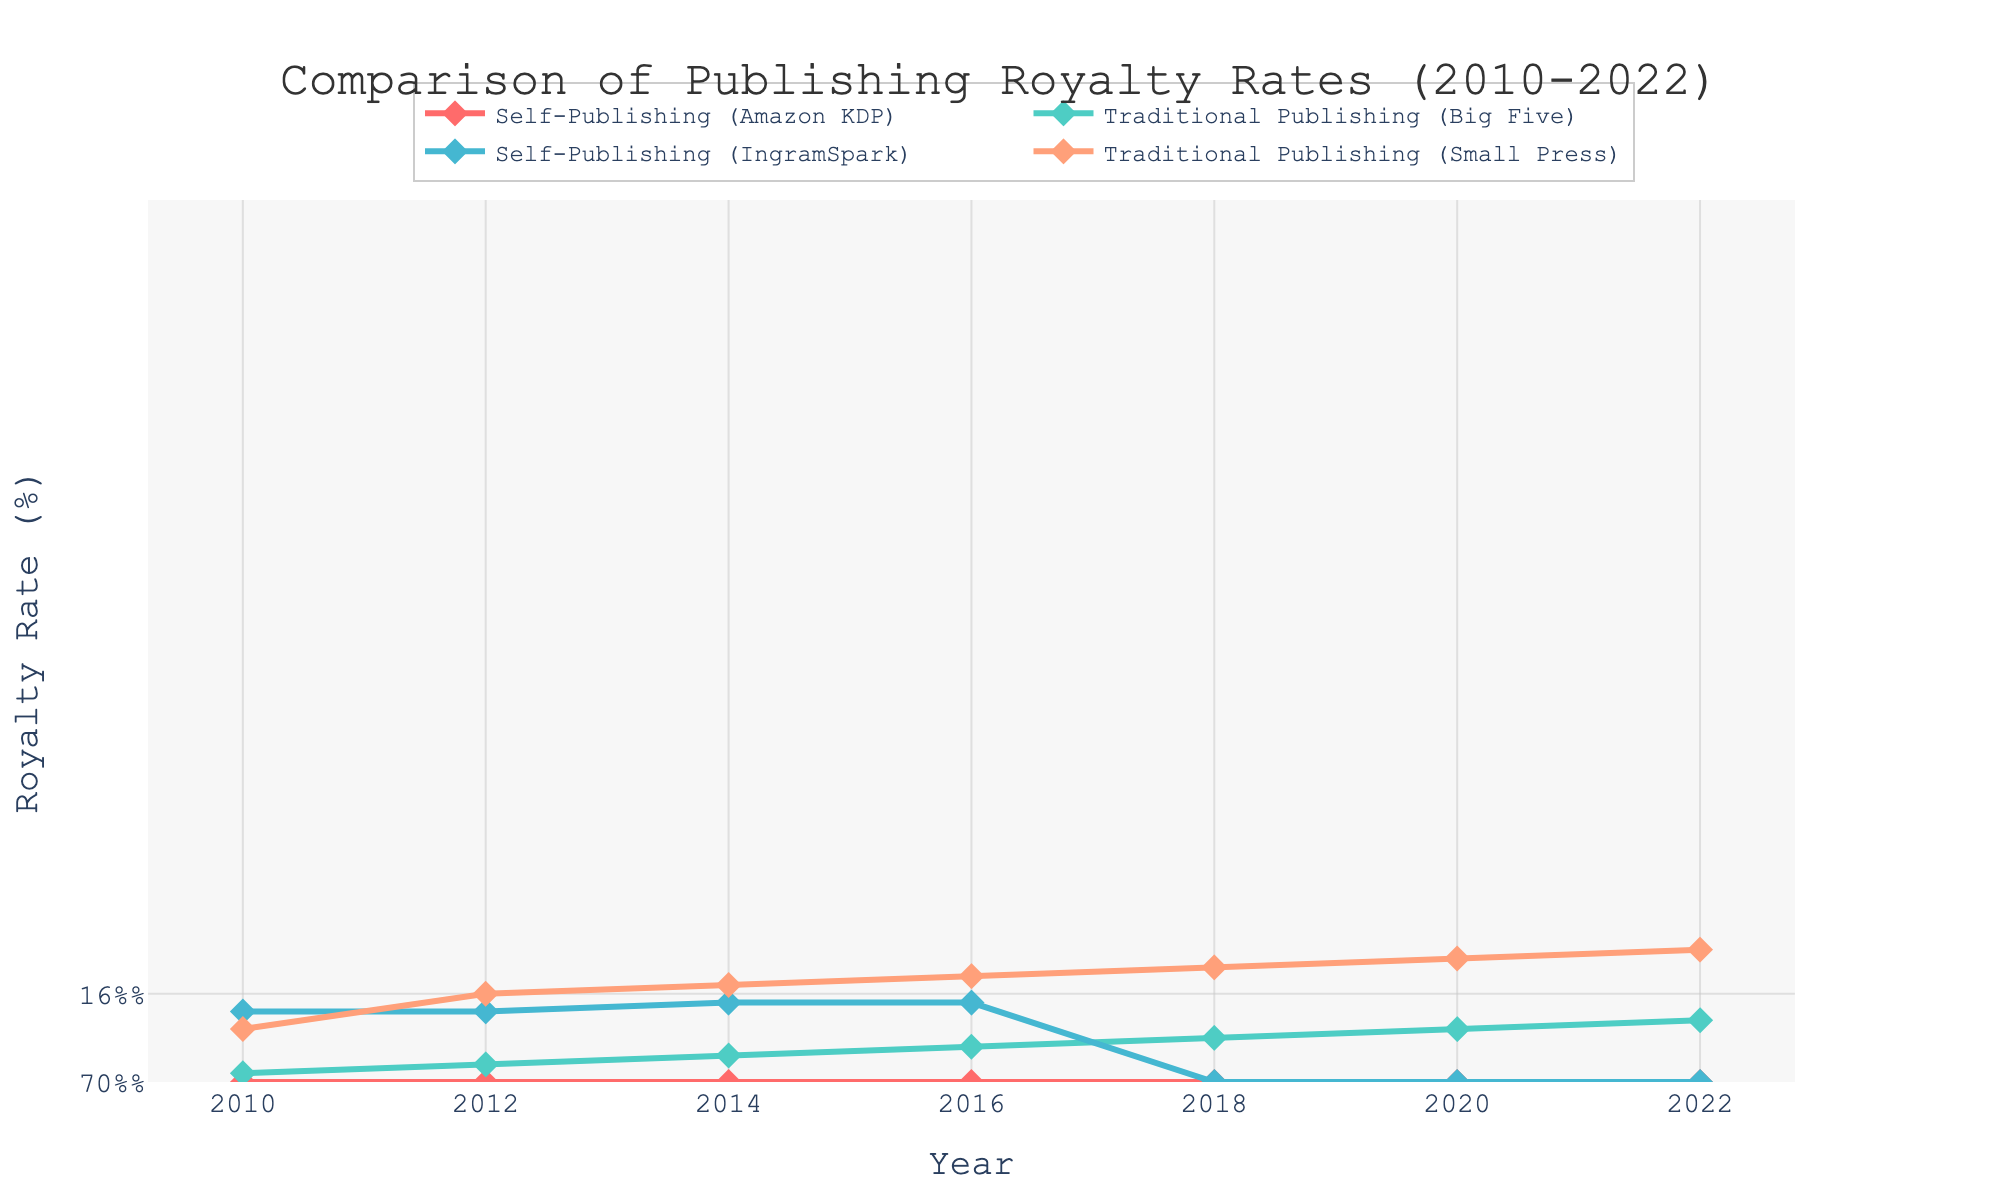Which publishing method had the highest royalty rate in 2022? By examining the figure, we can see that Self-Publishing (Amazon KDP) and Self-Publishing (IngramSpark) both had a royalty rate of 70% in 2022.
Answer: Self-Publishing (Amazon KDP) and Self-Publishing (IngramSpark) What is the difference in royalty rate between Traditional Publishing (Big Five) and Traditional Publishing (Small Press) in 2016? The royalty rate for Traditional Publishing (Big Five) in 2016 was 14%, while for Traditional Publishing (Small Press) it was 18%. The difference between them is calculated as 18% - 14% = 4%.
Answer: 4% Which publishing option had the lowest increase in royalty rates from 2010 to 2022? We can calculate the increase for each option by subtracting the 2010 rate from the 2022 rate. Self-Publishing (Amazon KDP) increased from 70% to 70% (0% increase), Traditional Publishing (Big Five) increased from 12.5% to 15.5% (3% increase), Self-Publishing (IngramSpark) increased from 60% to 70% (10% increase), and Traditional Publishing (Small Press) increased from 15% to 20% (5% increase). Therefore, Self-Publishing (Amazon KDP) had the lowest increase with a 0% change.
Answer: Self-Publishing (Amazon KDP) Which publishing method consistently maintained the same royalty rate over the years studied? By observing the lines, we can see that the line representing Self-Publishing (Amazon KDP) does not change over the years, maintaining a consistent 70% royalty rate.
Answer: Self-Publishing (Amazon KDP) Between which consecutive years did Self-Publishing (IngramSpark) see the largest increase in royalty rates? By examining the figure, we see that Self-Publishing (IngramSpark) increased from 60% in 2014 to 65% in 2014, which is an increase of 5%. This is the largest increase between consecutive years for Self-Publishing (IngramSpark).
Answer: 2014-2016 What is the average royalty rate of Traditional Publishing (Big Five) over the entire period? We find the average by adding the rates for Traditional Publishing (Big Five) over the years: (12.5% + 13% + 13.5% + 14% + 14.5% + 15% + 15.5%) and dividing by the number of years (7). The sum is 98%, so the average is 98%/7 = 14%.
Answer: 14% Which publishing method showed a visual change in marker symbol in the plotted figure? The visual characteristics indicate that platform's traces are represented by different symbols. We observe that all publishing methods have diamond markers, and there is no visual change in marker symbols across methods.
Answer: No visual change in marker symbol What is the range of royalty rates observed for Traditional Publishing (Small Press) over the years? The lowest royalty rate for Traditional Publishing (Small Press) is 15% in 2010 and the highest is 20% in 2022. The range can be found by subtracting the lowest from the highest: 20% - 15% = 5%.
Answer: 5% By how much did the royalty rate for Self-Publishing (IngramSpark) increase from 2010 to 2014? The royalty rate for Self-Publishing (IngramSpark) in 2010 was 60%, and in 2014 it increased to 65%. The increase is calculated as 65% - 60% = 5%.
Answer: 5% 